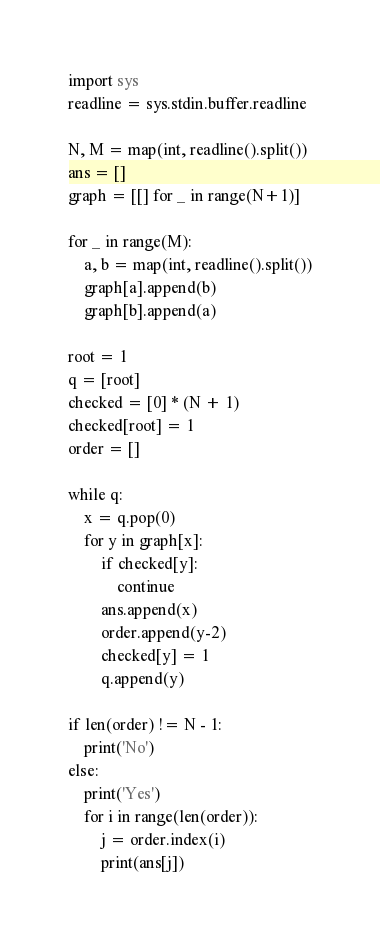<code> <loc_0><loc_0><loc_500><loc_500><_Python_>import sys
readline = sys.stdin.buffer.readline

N, M = map(int, readline().split())
ans = []
graph = [[] for _ in range(N+1)]

for _ in range(M):
    a, b = map(int, readline().split())
    graph[a].append(b)
    graph[b].append(a)

root = 1
q = [root]
checked = [0] * (N + 1)
checked[root] = 1
order = []

while q:
    x = q.pop(0)
    for y in graph[x]:
        if checked[y]:
            continue
        ans.append(x)
        order.append(y-2)
        checked[y] = 1
        q.append(y)

if len(order) != N - 1:
    print('No')
else:
    print('Yes')
    for i in range(len(order)):
        j = order.index(i)
        print(ans[j])</code> 